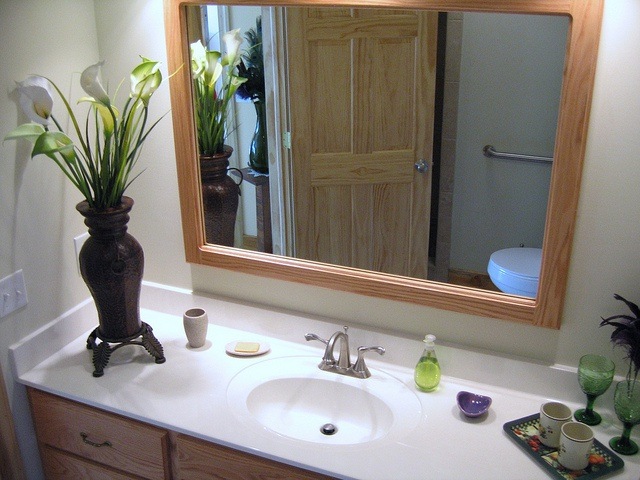Describe the objects in this image and their specific colors. I can see sink in gray, lavender, darkgray, and black tones, vase in gray, black, and darkgray tones, vase in gray and black tones, cup in gray, darkgray, and darkgreen tones, and toilet in gray and lightblue tones in this image. 